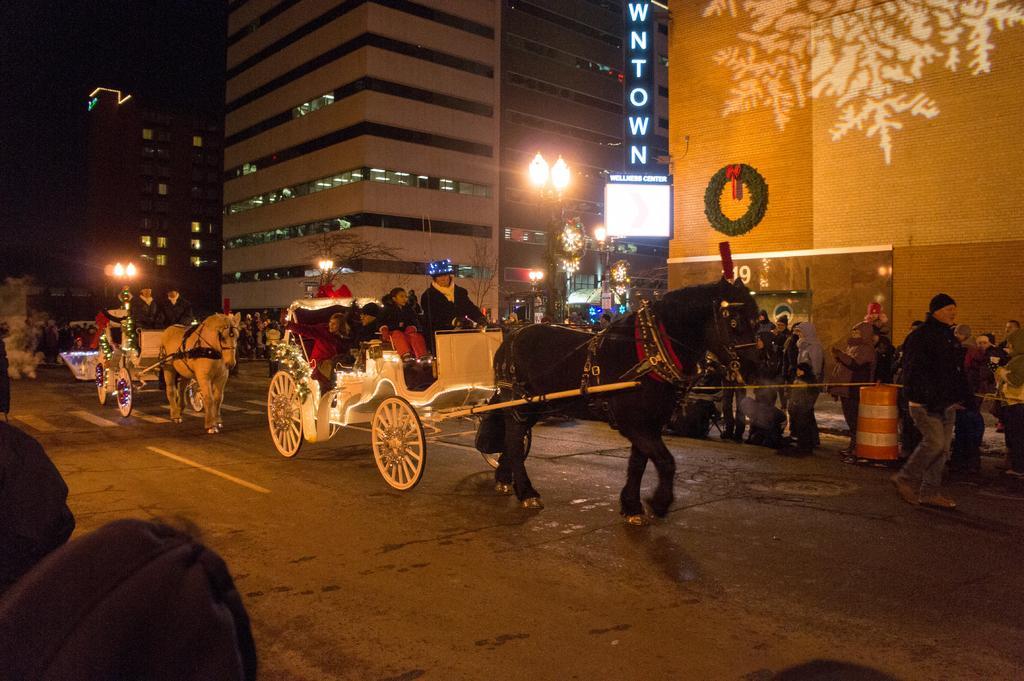How would you summarize this image in a sentence or two? In this picture I can see few people are travelling in the cart on the road. On the top of the image there is a building. I can see few people are walking on the footpath. On the left corner there are few street lights. 